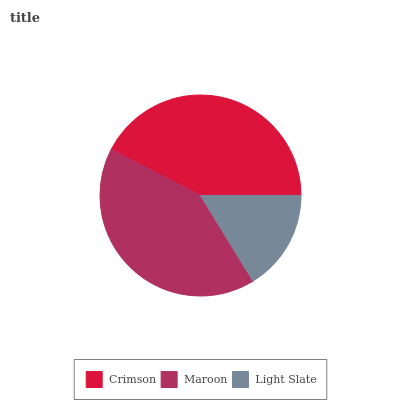Is Light Slate the minimum?
Answer yes or no. Yes. Is Crimson the maximum?
Answer yes or no. Yes. Is Maroon the minimum?
Answer yes or no. No. Is Maroon the maximum?
Answer yes or no. No. Is Crimson greater than Maroon?
Answer yes or no. Yes. Is Maroon less than Crimson?
Answer yes or no. Yes. Is Maroon greater than Crimson?
Answer yes or no. No. Is Crimson less than Maroon?
Answer yes or no. No. Is Maroon the high median?
Answer yes or no. Yes. Is Maroon the low median?
Answer yes or no. Yes. Is Crimson the high median?
Answer yes or no. No. Is Light Slate the low median?
Answer yes or no. No. 